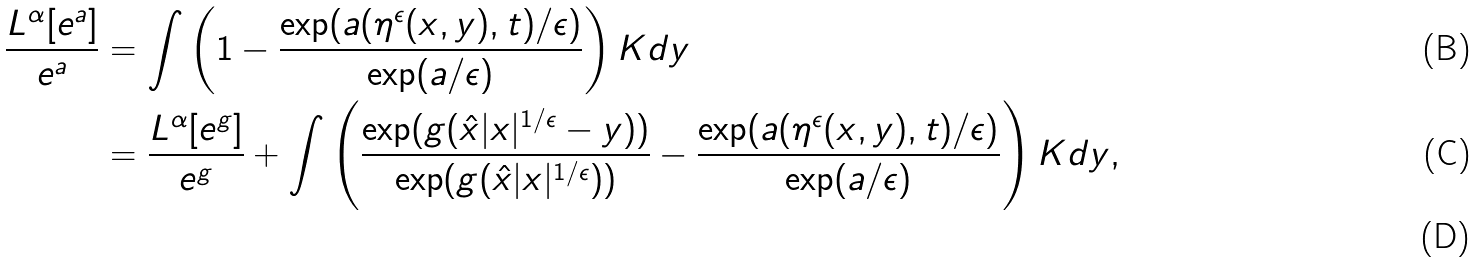<formula> <loc_0><loc_0><loc_500><loc_500>\frac { L ^ { \alpha } [ e ^ { a } ] } { e ^ { a } } & = \int \left ( 1 - \frac { \exp ( a ( \eta ^ { \epsilon } ( x , y ) , t ) / \epsilon ) } { \exp ( a / \epsilon ) } \right ) K d y \\ & = \frac { L ^ { \alpha } [ e ^ { g } ] } { e ^ { g } } + \int \left ( \frac { \exp ( g ( \hat { x } | x | ^ { 1 / \epsilon } - y ) ) } { \exp ( g ( \hat { x } | x | ^ { 1 / \epsilon } ) ) } - \frac { \exp ( a ( \eta ^ { \epsilon } ( x , y ) , t ) / \epsilon ) } { \exp ( a / \epsilon ) } \right ) K d y , \\</formula> 